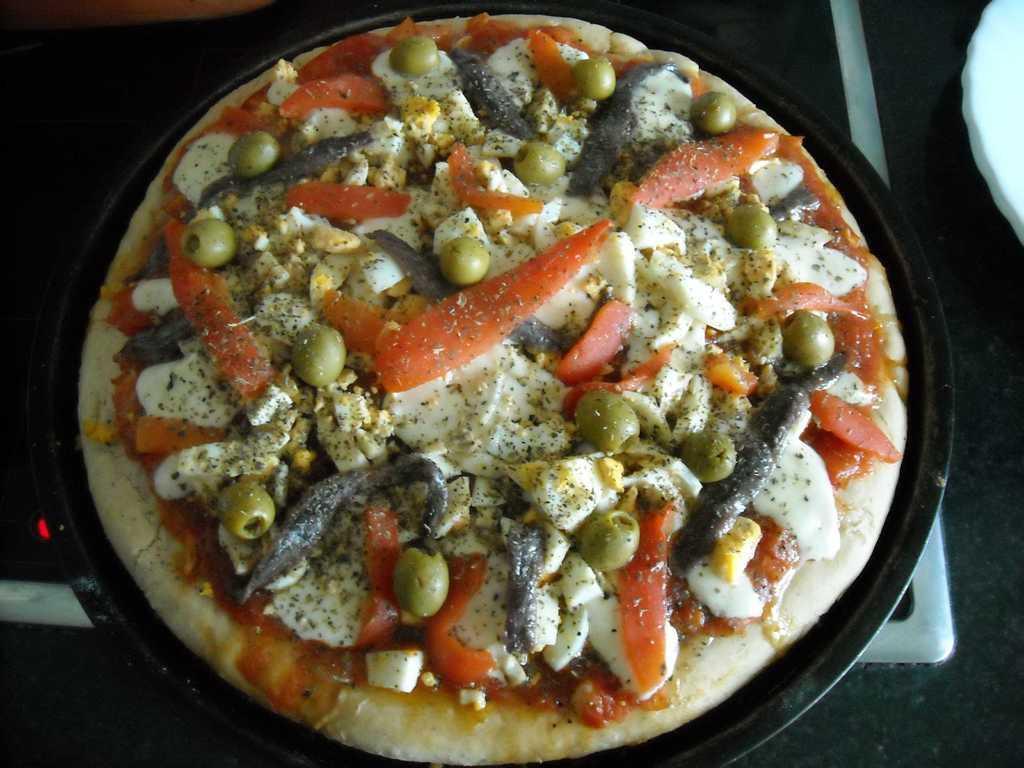How would you summarize this image in a sentence or two? In this picture we can see a pizza on a pan and this pan is on a stove. 